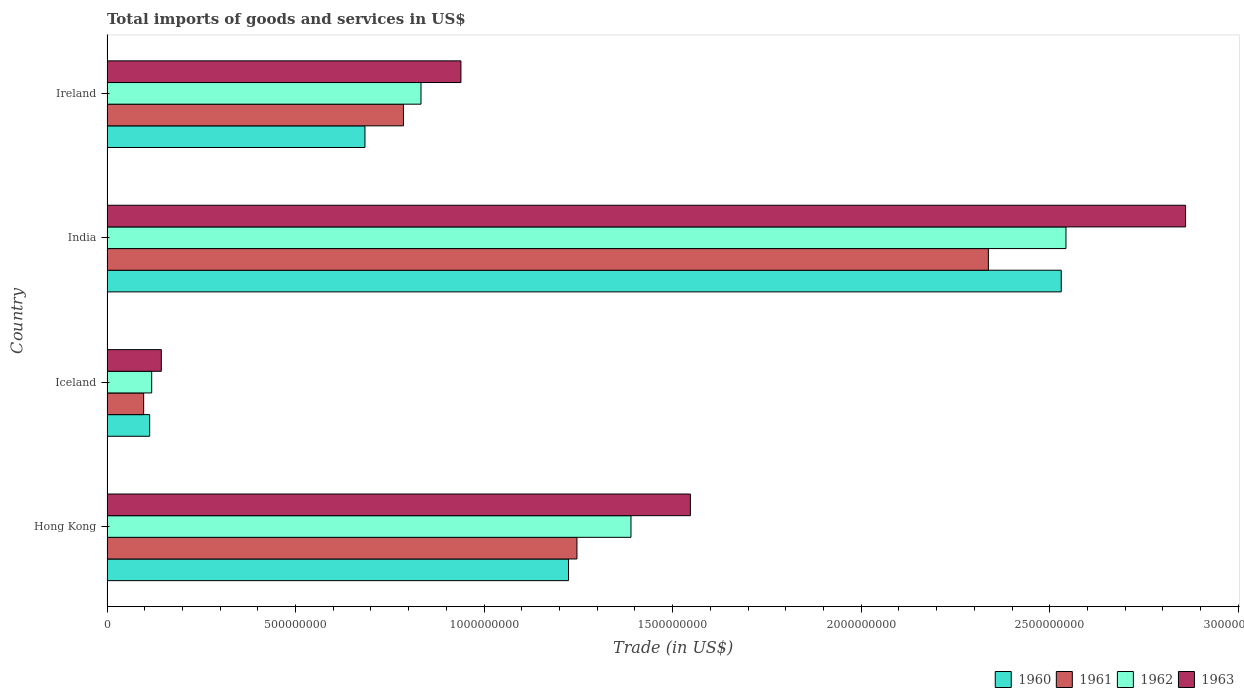Are the number of bars on each tick of the Y-axis equal?
Keep it short and to the point. Yes. What is the label of the 1st group of bars from the top?
Your response must be concise. Ireland. What is the total imports of goods and services in 1963 in Ireland?
Your response must be concise. 9.39e+08. Across all countries, what is the maximum total imports of goods and services in 1961?
Offer a very short reply. 2.34e+09. Across all countries, what is the minimum total imports of goods and services in 1960?
Provide a short and direct response. 1.13e+08. What is the total total imports of goods and services in 1960 in the graph?
Keep it short and to the point. 4.55e+09. What is the difference between the total imports of goods and services in 1960 in Iceland and that in India?
Provide a short and direct response. -2.42e+09. What is the difference between the total imports of goods and services in 1963 in Ireland and the total imports of goods and services in 1960 in Iceland?
Offer a very short reply. 8.25e+08. What is the average total imports of goods and services in 1961 per country?
Your answer should be compact. 1.12e+09. What is the difference between the total imports of goods and services in 1962 and total imports of goods and services in 1960 in Hong Kong?
Your response must be concise. 1.66e+08. In how many countries, is the total imports of goods and services in 1962 greater than 2600000000 US$?
Your answer should be very brief. 0. What is the ratio of the total imports of goods and services in 1963 in Hong Kong to that in Iceland?
Provide a short and direct response. 10.74. Is the difference between the total imports of goods and services in 1962 in Iceland and Ireland greater than the difference between the total imports of goods and services in 1960 in Iceland and Ireland?
Provide a succinct answer. No. What is the difference between the highest and the second highest total imports of goods and services in 1963?
Your answer should be very brief. 1.31e+09. What is the difference between the highest and the lowest total imports of goods and services in 1963?
Your answer should be very brief. 2.72e+09. In how many countries, is the total imports of goods and services in 1961 greater than the average total imports of goods and services in 1961 taken over all countries?
Your answer should be compact. 2. Is it the case that in every country, the sum of the total imports of goods and services in 1962 and total imports of goods and services in 1963 is greater than the sum of total imports of goods and services in 1961 and total imports of goods and services in 1960?
Provide a short and direct response. No. How many bars are there?
Ensure brevity in your answer.  16. Are all the bars in the graph horizontal?
Your answer should be compact. Yes. How many countries are there in the graph?
Ensure brevity in your answer.  4. What is the difference between two consecutive major ticks on the X-axis?
Your response must be concise. 5.00e+08. Does the graph contain grids?
Ensure brevity in your answer.  No. How are the legend labels stacked?
Give a very brief answer. Horizontal. What is the title of the graph?
Offer a terse response. Total imports of goods and services in US$. What is the label or title of the X-axis?
Ensure brevity in your answer.  Trade (in US$). What is the label or title of the Y-axis?
Give a very brief answer. Country. What is the Trade (in US$) in 1960 in Hong Kong?
Your response must be concise. 1.22e+09. What is the Trade (in US$) in 1961 in Hong Kong?
Offer a terse response. 1.25e+09. What is the Trade (in US$) in 1962 in Hong Kong?
Offer a terse response. 1.39e+09. What is the Trade (in US$) in 1963 in Hong Kong?
Your answer should be compact. 1.55e+09. What is the Trade (in US$) of 1960 in Iceland?
Provide a succinct answer. 1.13e+08. What is the Trade (in US$) of 1961 in Iceland?
Keep it short and to the point. 9.72e+07. What is the Trade (in US$) in 1962 in Iceland?
Give a very brief answer. 1.18e+08. What is the Trade (in US$) in 1963 in Iceland?
Your answer should be compact. 1.44e+08. What is the Trade (in US$) of 1960 in India?
Provide a succinct answer. 2.53e+09. What is the Trade (in US$) of 1961 in India?
Provide a short and direct response. 2.34e+09. What is the Trade (in US$) of 1962 in India?
Keep it short and to the point. 2.54e+09. What is the Trade (in US$) in 1963 in India?
Your answer should be compact. 2.86e+09. What is the Trade (in US$) in 1960 in Ireland?
Offer a terse response. 6.84e+08. What is the Trade (in US$) in 1961 in Ireland?
Keep it short and to the point. 7.86e+08. What is the Trade (in US$) in 1962 in Ireland?
Offer a very short reply. 8.33e+08. What is the Trade (in US$) of 1963 in Ireland?
Provide a succinct answer. 9.39e+08. Across all countries, what is the maximum Trade (in US$) of 1960?
Provide a succinct answer. 2.53e+09. Across all countries, what is the maximum Trade (in US$) of 1961?
Offer a terse response. 2.34e+09. Across all countries, what is the maximum Trade (in US$) of 1962?
Give a very brief answer. 2.54e+09. Across all countries, what is the maximum Trade (in US$) in 1963?
Provide a succinct answer. 2.86e+09. Across all countries, what is the minimum Trade (in US$) in 1960?
Keep it short and to the point. 1.13e+08. Across all countries, what is the minimum Trade (in US$) of 1961?
Keep it short and to the point. 9.72e+07. Across all countries, what is the minimum Trade (in US$) in 1962?
Provide a short and direct response. 1.18e+08. Across all countries, what is the minimum Trade (in US$) of 1963?
Offer a terse response. 1.44e+08. What is the total Trade (in US$) in 1960 in the graph?
Ensure brevity in your answer.  4.55e+09. What is the total Trade (in US$) in 1961 in the graph?
Ensure brevity in your answer.  4.47e+09. What is the total Trade (in US$) in 1962 in the graph?
Provide a succinct answer. 4.88e+09. What is the total Trade (in US$) in 1963 in the graph?
Provide a short and direct response. 5.49e+09. What is the difference between the Trade (in US$) in 1960 in Hong Kong and that in Iceland?
Offer a very short reply. 1.11e+09. What is the difference between the Trade (in US$) in 1961 in Hong Kong and that in Iceland?
Offer a terse response. 1.15e+09. What is the difference between the Trade (in US$) of 1962 in Hong Kong and that in Iceland?
Ensure brevity in your answer.  1.27e+09. What is the difference between the Trade (in US$) in 1963 in Hong Kong and that in Iceland?
Give a very brief answer. 1.40e+09. What is the difference between the Trade (in US$) of 1960 in Hong Kong and that in India?
Ensure brevity in your answer.  -1.31e+09. What is the difference between the Trade (in US$) in 1961 in Hong Kong and that in India?
Provide a succinct answer. -1.09e+09. What is the difference between the Trade (in US$) in 1962 in Hong Kong and that in India?
Your answer should be very brief. -1.15e+09. What is the difference between the Trade (in US$) of 1963 in Hong Kong and that in India?
Provide a short and direct response. -1.31e+09. What is the difference between the Trade (in US$) in 1960 in Hong Kong and that in Ireland?
Make the answer very short. 5.40e+08. What is the difference between the Trade (in US$) in 1961 in Hong Kong and that in Ireland?
Offer a terse response. 4.60e+08. What is the difference between the Trade (in US$) of 1962 in Hong Kong and that in Ireland?
Make the answer very short. 5.57e+08. What is the difference between the Trade (in US$) in 1963 in Hong Kong and that in Ireland?
Offer a very short reply. 6.08e+08. What is the difference between the Trade (in US$) in 1960 in Iceland and that in India?
Your answer should be very brief. -2.42e+09. What is the difference between the Trade (in US$) in 1961 in Iceland and that in India?
Your response must be concise. -2.24e+09. What is the difference between the Trade (in US$) in 1962 in Iceland and that in India?
Offer a very short reply. -2.42e+09. What is the difference between the Trade (in US$) of 1963 in Iceland and that in India?
Ensure brevity in your answer.  -2.72e+09. What is the difference between the Trade (in US$) of 1960 in Iceland and that in Ireland?
Keep it short and to the point. -5.71e+08. What is the difference between the Trade (in US$) of 1961 in Iceland and that in Ireland?
Ensure brevity in your answer.  -6.89e+08. What is the difference between the Trade (in US$) of 1962 in Iceland and that in Ireland?
Offer a very short reply. -7.14e+08. What is the difference between the Trade (in US$) in 1963 in Iceland and that in Ireland?
Provide a succinct answer. -7.95e+08. What is the difference between the Trade (in US$) of 1960 in India and that in Ireland?
Make the answer very short. 1.85e+09. What is the difference between the Trade (in US$) in 1961 in India and that in Ireland?
Your response must be concise. 1.55e+09. What is the difference between the Trade (in US$) in 1962 in India and that in Ireland?
Your answer should be very brief. 1.71e+09. What is the difference between the Trade (in US$) of 1963 in India and that in Ireland?
Provide a succinct answer. 1.92e+09. What is the difference between the Trade (in US$) of 1960 in Hong Kong and the Trade (in US$) of 1961 in Iceland?
Offer a terse response. 1.13e+09. What is the difference between the Trade (in US$) of 1960 in Hong Kong and the Trade (in US$) of 1962 in Iceland?
Give a very brief answer. 1.11e+09. What is the difference between the Trade (in US$) in 1960 in Hong Kong and the Trade (in US$) in 1963 in Iceland?
Give a very brief answer. 1.08e+09. What is the difference between the Trade (in US$) in 1961 in Hong Kong and the Trade (in US$) in 1962 in Iceland?
Your answer should be compact. 1.13e+09. What is the difference between the Trade (in US$) in 1961 in Hong Kong and the Trade (in US$) in 1963 in Iceland?
Offer a very short reply. 1.10e+09. What is the difference between the Trade (in US$) of 1962 in Hong Kong and the Trade (in US$) of 1963 in Iceland?
Your response must be concise. 1.25e+09. What is the difference between the Trade (in US$) in 1960 in Hong Kong and the Trade (in US$) in 1961 in India?
Offer a very short reply. -1.11e+09. What is the difference between the Trade (in US$) of 1960 in Hong Kong and the Trade (in US$) of 1962 in India?
Provide a succinct answer. -1.32e+09. What is the difference between the Trade (in US$) in 1960 in Hong Kong and the Trade (in US$) in 1963 in India?
Ensure brevity in your answer.  -1.64e+09. What is the difference between the Trade (in US$) in 1961 in Hong Kong and the Trade (in US$) in 1962 in India?
Provide a short and direct response. -1.30e+09. What is the difference between the Trade (in US$) in 1961 in Hong Kong and the Trade (in US$) in 1963 in India?
Provide a short and direct response. -1.61e+09. What is the difference between the Trade (in US$) in 1962 in Hong Kong and the Trade (in US$) in 1963 in India?
Offer a very short reply. -1.47e+09. What is the difference between the Trade (in US$) of 1960 in Hong Kong and the Trade (in US$) of 1961 in Ireland?
Your response must be concise. 4.38e+08. What is the difference between the Trade (in US$) of 1960 in Hong Kong and the Trade (in US$) of 1962 in Ireland?
Give a very brief answer. 3.91e+08. What is the difference between the Trade (in US$) of 1960 in Hong Kong and the Trade (in US$) of 1963 in Ireland?
Give a very brief answer. 2.85e+08. What is the difference between the Trade (in US$) in 1961 in Hong Kong and the Trade (in US$) in 1962 in Ireland?
Provide a short and direct response. 4.14e+08. What is the difference between the Trade (in US$) of 1961 in Hong Kong and the Trade (in US$) of 1963 in Ireland?
Make the answer very short. 3.08e+08. What is the difference between the Trade (in US$) of 1962 in Hong Kong and the Trade (in US$) of 1963 in Ireland?
Your answer should be very brief. 4.51e+08. What is the difference between the Trade (in US$) of 1960 in Iceland and the Trade (in US$) of 1961 in India?
Give a very brief answer. -2.22e+09. What is the difference between the Trade (in US$) of 1960 in Iceland and the Trade (in US$) of 1962 in India?
Provide a succinct answer. -2.43e+09. What is the difference between the Trade (in US$) of 1960 in Iceland and the Trade (in US$) of 1963 in India?
Your response must be concise. -2.75e+09. What is the difference between the Trade (in US$) in 1961 in Iceland and the Trade (in US$) in 1962 in India?
Keep it short and to the point. -2.45e+09. What is the difference between the Trade (in US$) in 1961 in Iceland and the Trade (in US$) in 1963 in India?
Provide a short and direct response. -2.76e+09. What is the difference between the Trade (in US$) in 1962 in Iceland and the Trade (in US$) in 1963 in India?
Ensure brevity in your answer.  -2.74e+09. What is the difference between the Trade (in US$) of 1960 in Iceland and the Trade (in US$) of 1961 in Ireland?
Your response must be concise. -6.73e+08. What is the difference between the Trade (in US$) of 1960 in Iceland and the Trade (in US$) of 1962 in Ireland?
Keep it short and to the point. -7.20e+08. What is the difference between the Trade (in US$) in 1960 in Iceland and the Trade (in US$) in 1963 in Ireland?
Keep it short and to the point. -8.25e+08. What is the difference between the Trade (in US$) in 1961 in Iceland and the Trade (in US$) in 1962 in Ireland?
Provide a short and direct response. -7.35e+08. What is the difference between the Trade (in US$) in 1961 in Iceland and the Trade (in US$) in 1963 in Ireland?
Ensure brevity in your answer.  -8.41e+08. What is the difference between the Trade (in US$) of 1962 in Iceland and the Trade (in US$) of 1963 in Ireland?
Provide a short and direct response. -8.20e+08. What is the difference between the Trade (in US$) in 1960 in India and the Trade (in US$) in 1961 in Ireland?
Offer a terse response. 1.74e+09. What is the difference between the Trade (in US$) of 1960 in India and the Trade (in US$) of 1962 in Ireland?
Your answer should be compact. 1.70e+09. What is the difference between the Trade (in US$) of 1960 in India and the Trade (in US$) of 1963 in Ireland?
Ensure brevity in your answer.  1.59e+09. What is the difference between the Trade (in US$) of 1961 in India and the Trade (in US$) of 1962 in Ireland?
Make the answer very short. 1.50e+09. What is the difference between the Trade (in US$) in 1961 in India and the Trade (in US$) in 1963 in Ireland?
Provide a short and direct response. 1.40e+09. What is the difference between the Trade (in US$) in 1962 in India and the Trade (in US$) in 1963 in Ireland?
Make the answer very short. 1.60e+09. What is the average Trade (in US$) of 1960 per country?
Your answer should be very brief. 1.14e+09. What is the average Trade (in US$) in 1961 per country?
Your answer should be compact. 1.12e+09. What is the average Trade (in US$) of 1962 per country?
Offer a terse response. 1.22e+09. What is the average Trade (in US$) in 1963 per country?
Give a very brief answer. 1.37e+09. What is the difference between the Trade (in US$) of 1960 and Trade (in US$) of 1961 in Hong Kong?
Give a very brief answer. -2.23e+07. What is the difference between the Trade (in US$) in 1960 and Trade (in US$) in 1962 in Hong Kong?
Offer a terse response. -1.66e+08. What is the difference between the Trade (in US$) of 1960 and Trade (in US$) of 1963 in Hong Kong?
Make the answer very short. -3.23e+08. What is the difference between the Trade (in US$) in 1961 and Trade (in US$) in 1962 in Hong Kong?
Give a very brief answer. -1.43e+08. What is the difference between the Trade (in US$) in 1961 and Trade (in US$) in 1963 in Hong Kong?
Keep it short and to the point. -3.01e+08. What is the difference between the Trade (in US$) of 1962 and Trade (in US$) of 1963 in Hong Kong?
Provide a succinct answer. -1.57e+08. What is the difference between the Trade (in US$) of 1960 and Trade (in US$) of 1961 in Iceland?
Your answer should be compact. 1.60e+07. What is the difference between the Trade (in US$) in 1960 and Trade (in US$) in 1962 in Iceland?
Offer a very short reply. -5.31e+06. What is the difference between the Trade (in US$) in 1960 and Trade (in US$) in 1963 in Iceland?
Give a very brief answer. -3.09e+07. What is the difference between the Trade (in US$) in 1961 and Trade (in US$) in 1962 in Iceland?
Provide a short and direct response. -2.13e+07. What is the difference between the Trade (in US$) in 1961 and Trade (in US$) in 1963 in Iceland?
Offer a terse response. -4.68e+07. What is the difference between the Trade (in US$) of 1962 and Trade (in US$) of 1963 in Iceland?
Keep it short and to the point. -2.56e+07. What is the difference between the Trade (in US$) in 1960 and Trade (in US$) in 1961 in India?
Provide a short and direct response. 1.93e+08. What is the difference between the Trade (in US$) in 1960 and Trade (in US$) in 1962 in India?
Provide a short and direct response. -1.26e+07. What is the difference between the Trade (in US$) in 1960 and Trade (in US$) in 1963 in India?
Your response must be concise. -3.30e+08. What is the difference between the Trade (in US$) of 1961 and Trade (in US$) of 1962 in India?
Offer a terse response. -2.06e+08. What is the difference between the Trade (in US$) in 1961 and Trade (in US$) in 1963 in India?
Ensure brevity in your answer.  -5.23e+08. What is the difference between the Trade (in US$) of 1962 and Trade (in US$) of 1963 in India?
Make the answer very short. -3.17e+08. What is the difference between the Trade (in US$) in 1960 and Trade (in US$) in 1961 in Ireland?
Provide a short and direct response. -1.02e+08. What is the difference between the Trade (in US$) in 1960 and Trade (in US$) in 1962 in Ireland?
Your answer should be very brief. -1.49e+08. What is the difference between the Trade (in US$) in 1960 and Trade (in US$) in 1963 in Ireland?
Give a very brief answer. -2.54e+08. What is the difference between the Trade (in US$) in 1961 and Trade (in US$) in 1962 in Ireland?
Make the answer very short. -4.65e+07. What is the difference between the Trade (in US$) of 1961 and Trade (in US$) of 1963 in Ireland?
Keep it short and to the point. -1.52e+08. What is the difference between the Trade (in US$) in 1962 and Trade (in US$) in 1963 in Ireland?
Offer a very short reply. -1.06e+08. What is the ratio of the Trade (in US$) in 1960 in Hong Kong to that in Iceland?
Your response must be concise. 10.81. What is the ratio of the Trade (in US$) of 1961 in Hong Kong to that in Iceland?
Offer a terse response. 12.82. What is the ratio of the Trade (in US$) in 1962 in Hong Kong to that in Iceland?
Keep it short and to the point. 11.73. What is the ratio of the Trade (in US$) in 1963 in Hong Kong to that in Iceland?
Offer a terse response. 10.74. What is the ratio of the Trade (in US$) of 1960 in Hong Kong to that in India?
Provide a short and direct response. 0.48. What is the ratio of the Trade (in US$) in 1961 in Hong Kong to that in India?
Your answer should be compact. 0.53. What is the ratio of the Trade (in US$) in 1962 in Hong Kong to that in India?
Provide a succinct answer. 0.55. What is the ratio of the Trade (in US$) of 1963 in Hong Kong to that in India?
Offer a terse response. 0.54. What is the ratio of the Trade (in US$) in 1960 in Hong Kong to that in Ireland?
Offer a very short reply. 1.79. What is the ratio of the Trade (in US$) in 1961 in Hong Kong to that in Ireland?
Make the answer very short. 1.59. What is the ratio of the Trade (in US$) in 1962 in Hong Kong to that in Ireland?
Your answer should be very brief. 1.67. What is the ratio of the Trade (in US$) in 1963 in Hong Kong to that in Ireland?
Make the answer very short. 1.65. What is the ratio of the Trade (in US$) in 1960 in Iceland to that in India?
Provide a succinct answer. 0.04. What is the ratio of the Trade (in US$) in 1961 in Iceland to that in India?
Your answer should be very brief. 0.04. What is the ratio of the Trade (in US$) of 1962 in Iceland to that in India?
Give a very brief answer. 0.05. What is the ratio of the Trade (in US$) of 1963 in Iceland to that in India?
Your answer should be very brief. 0.05. What is the ratio of the Trade (in US$) in 1960 in Iceland to that in Ireland?
Your answer should be very brief. 0.17. What is the ratio of the Trade (in US$) in 1961 in Iceland to that in Ireland?
Provide a succinct answer. 0.12. What is the ratio of the Trade (in US$) of 1962 in Iceland to that in Ireland?
Ensure brevity in your answer.  0.14. What is the ratio of the Trade (in US$) in 1963 in Iceland to that in Ireland?
Ensure brevity in your answer.  0.15. What is the ratio of the Trade (in US$) of 1960 in India to that in Ireland?
Your answer should be very brief. 3.7. What is the ratio of the Trade (in US$) of 1961 in India to that in Ireland?
Provide a succinct answer. 2.97. What is the ratio of the Trade (in US$) of 1962 in India to that in Ireland?
Offer a terse response. 3.05. What is the ratio of the Trade (in US$) in 1963 in India to that in Ireland?
Make the answer very short. 3.05. What is the difference between the highest and the second highest Trade (in US$) of 1960?
Your response must be concise. 1.31e+09. What is the difference between the highest and the second highest Trade (in US$) of 1961?
Provide a short and direct response. 1.09e+09. What is the difference between the highest and the second highest Trade (in US$) of 1962?
Provide a short and direct response. 1.15e+09. What is the difference between the highest and the second highest Trade (in US$) of 1963?
Provide a short and direct response. 1.31e+09. What is the difference between the highest and the lowest Trade (in US$) in 1960?
Your response must be concise. 2.42e+09. What is the difference between the highest and the lowest Trade (in US$) of 1961?
Your response must be concise. 2.24e+09. What is the difference between the highest and the lowest Trade (in US$) of 1962?
Make the answer very short. 2.42e+09. What is the difference between the highest and the lowest Trade (in US$) of 1963?
Provide a short and direct response. 2.72e+09. 